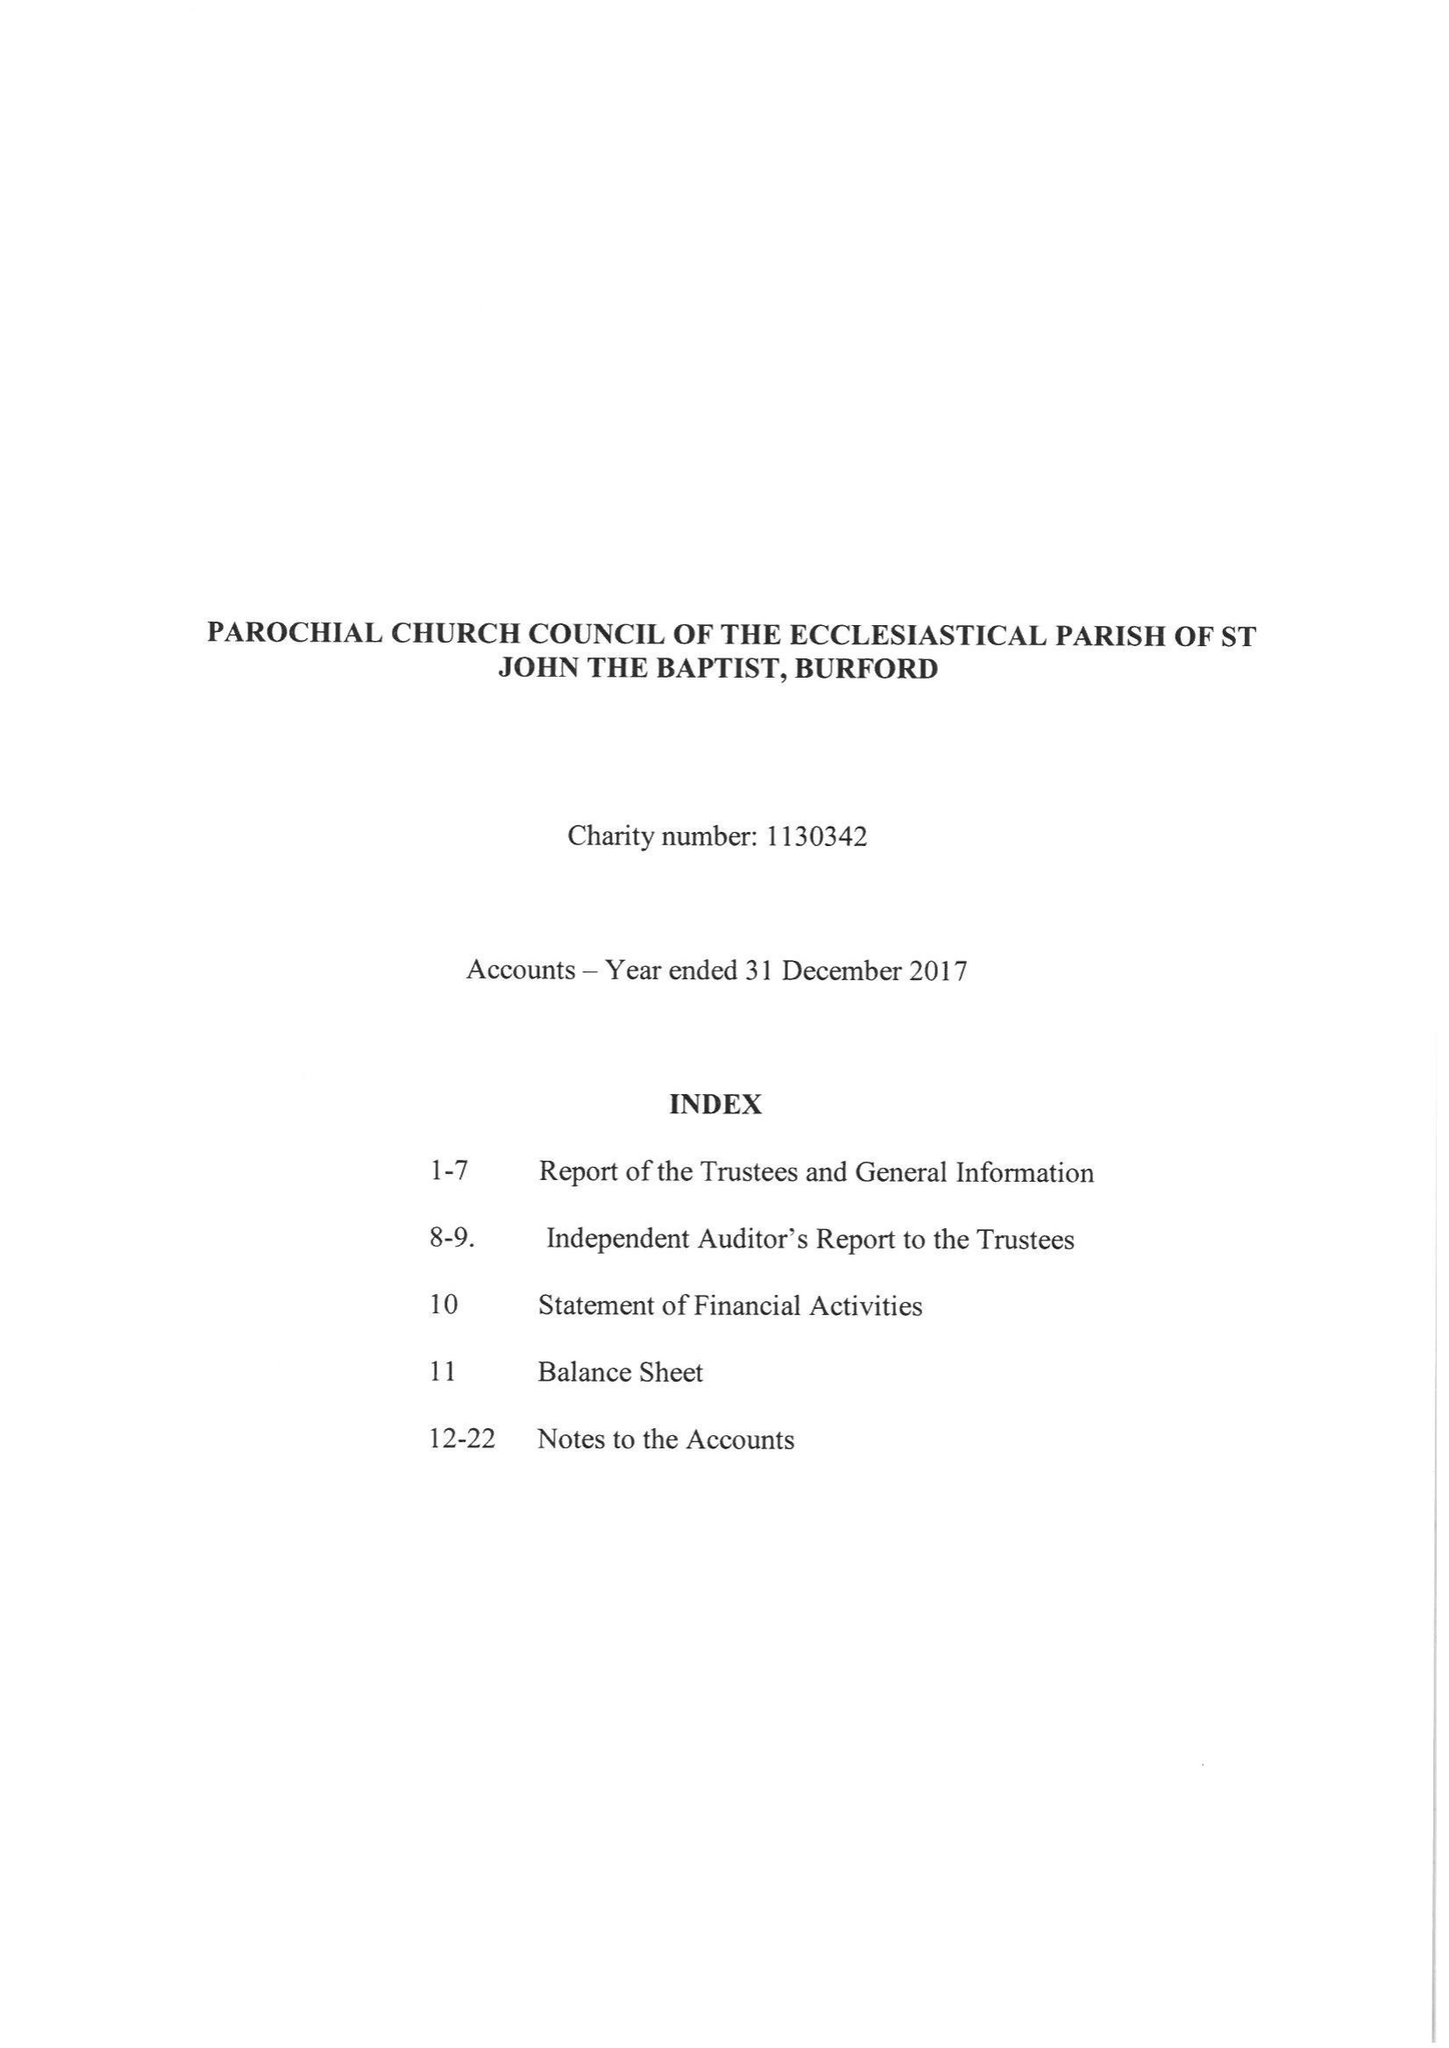What is the value for the charity_name?
Answer the question using a single word or phrase. The Parochial Church Council Of The Ecclesiastical Parish Of St John The Baptist, Burford 